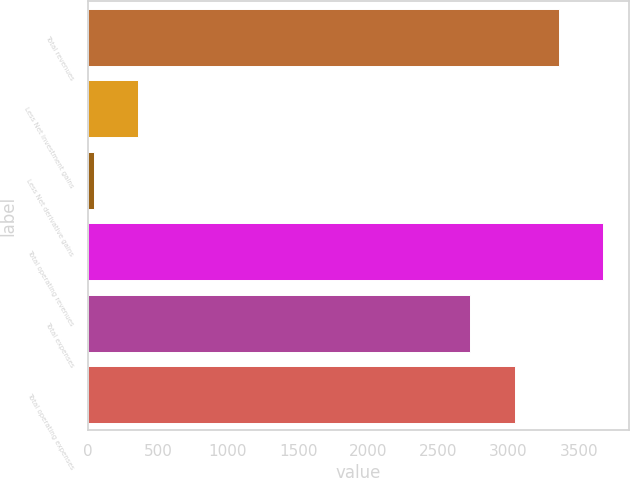<chart> <loc_0><loc_0><loc_500><loc_500><bar_chart><fcel>Total revenues<fcel>Less Net investment gains<fcel>Less Net derivative gains<fcel>Total operating revenues<fcel>Total expenses<fcel>Total operating expenses<nl><fcel>3358<fcel>360<fcel>45<fcel>3673<fcel>2728<fcel>3043<nl></chart> 